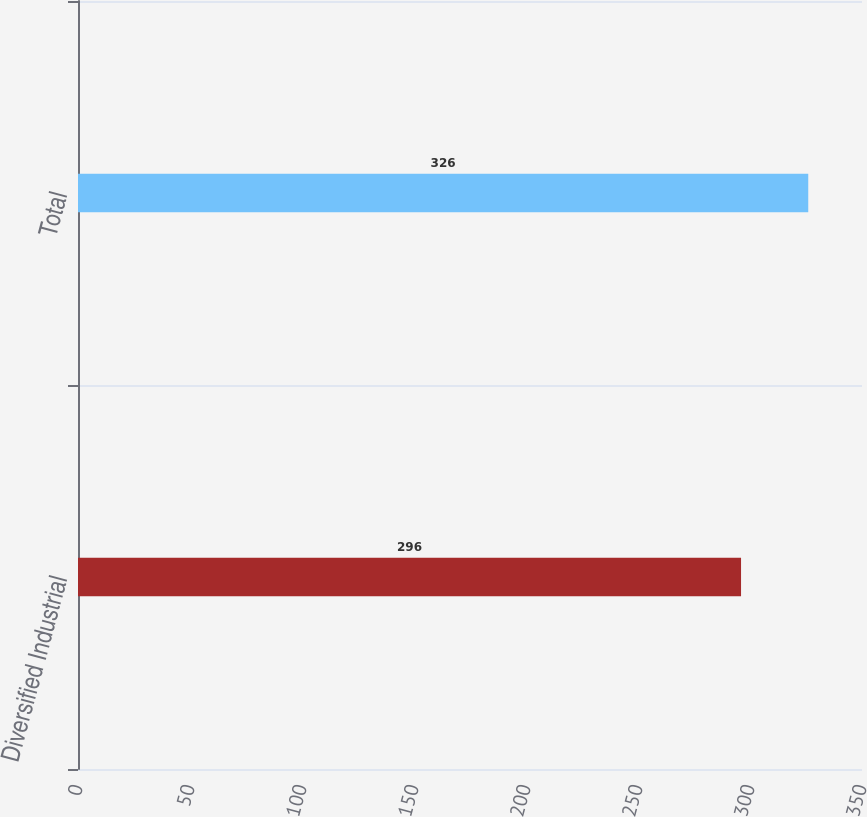<chart> <loc_0><loc_0><loc_500><loc_500><bar_chart><fcel>Diversified Industrial<fcel>Total<nl><fcel>296<fcel>326<nl></chart> 